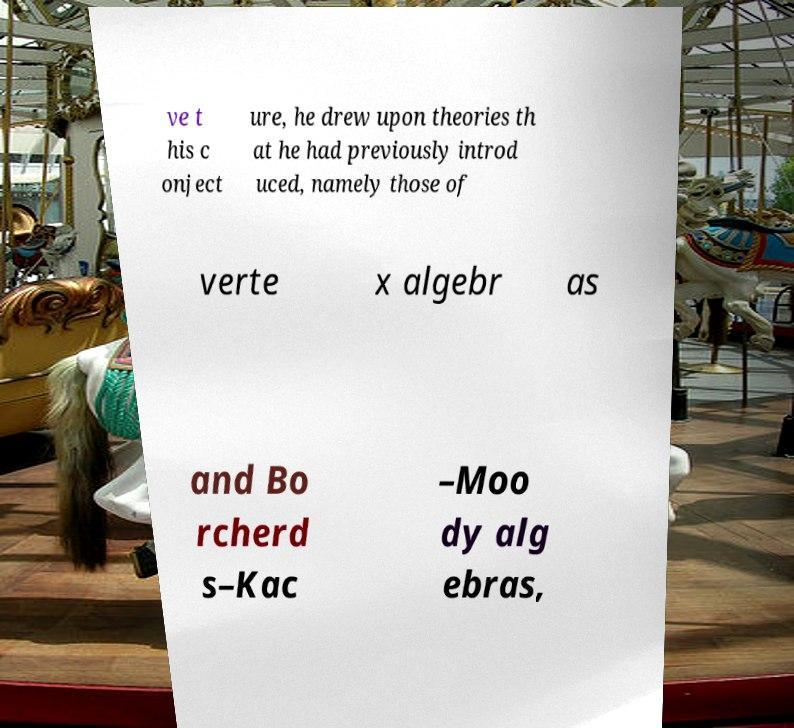Please read and relay the text visible in this image. What does it say? ve t his c onject ure, he drew upon theories th at he had previously introd uced, namely those of verte x algebr as and Bo rcherd s–Kac –Moo dy alg ebras, 